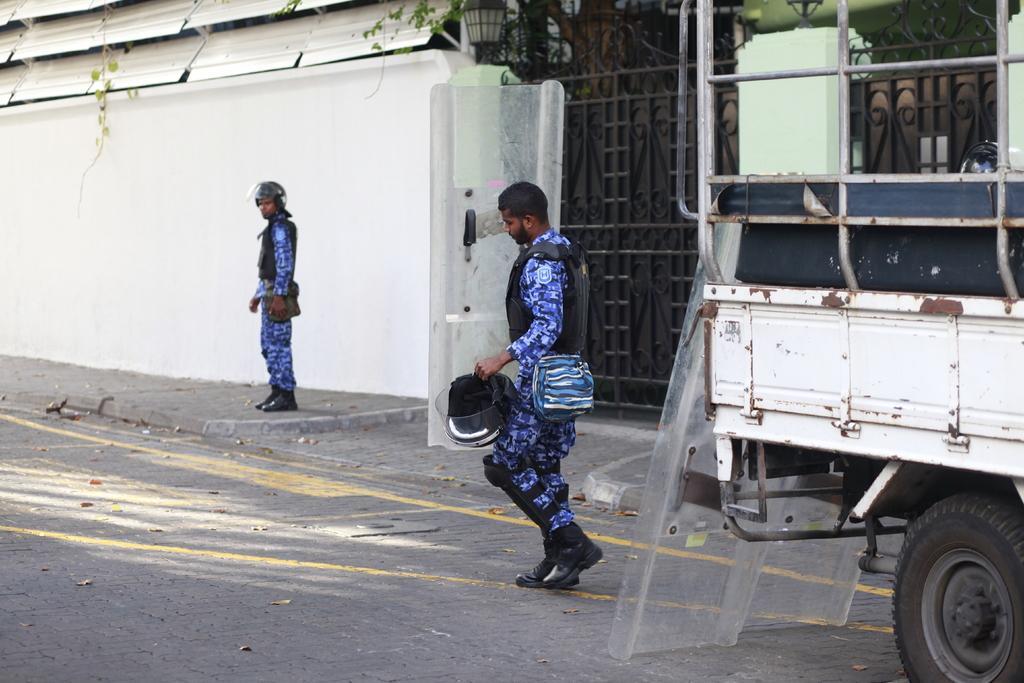Can you describe this image briefly? In the center of the image, we can see a person wearing uniform and a coat and holding a helmet and we can see a vehicle on the road. In the background, there is another person wearing helmet and uniform and we can see a building, lights and a gate. 